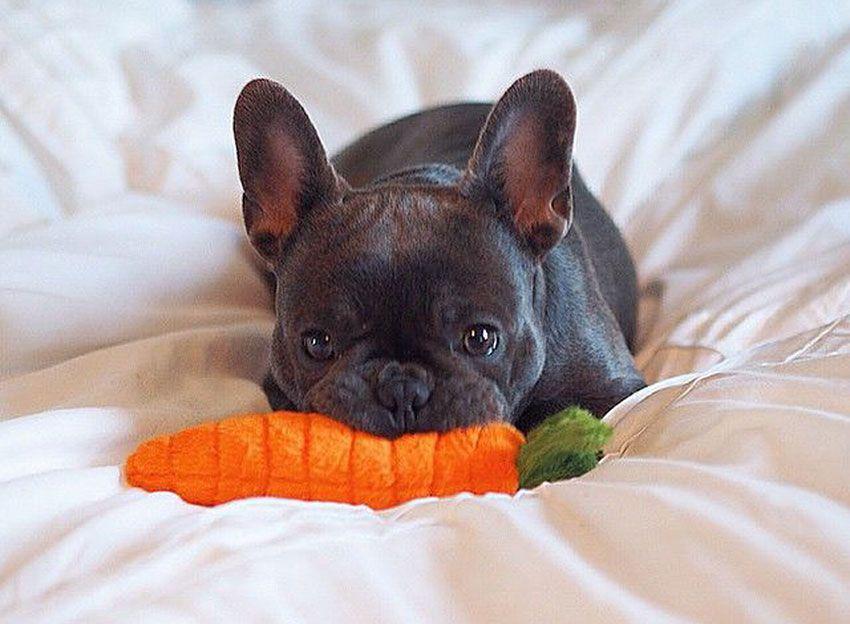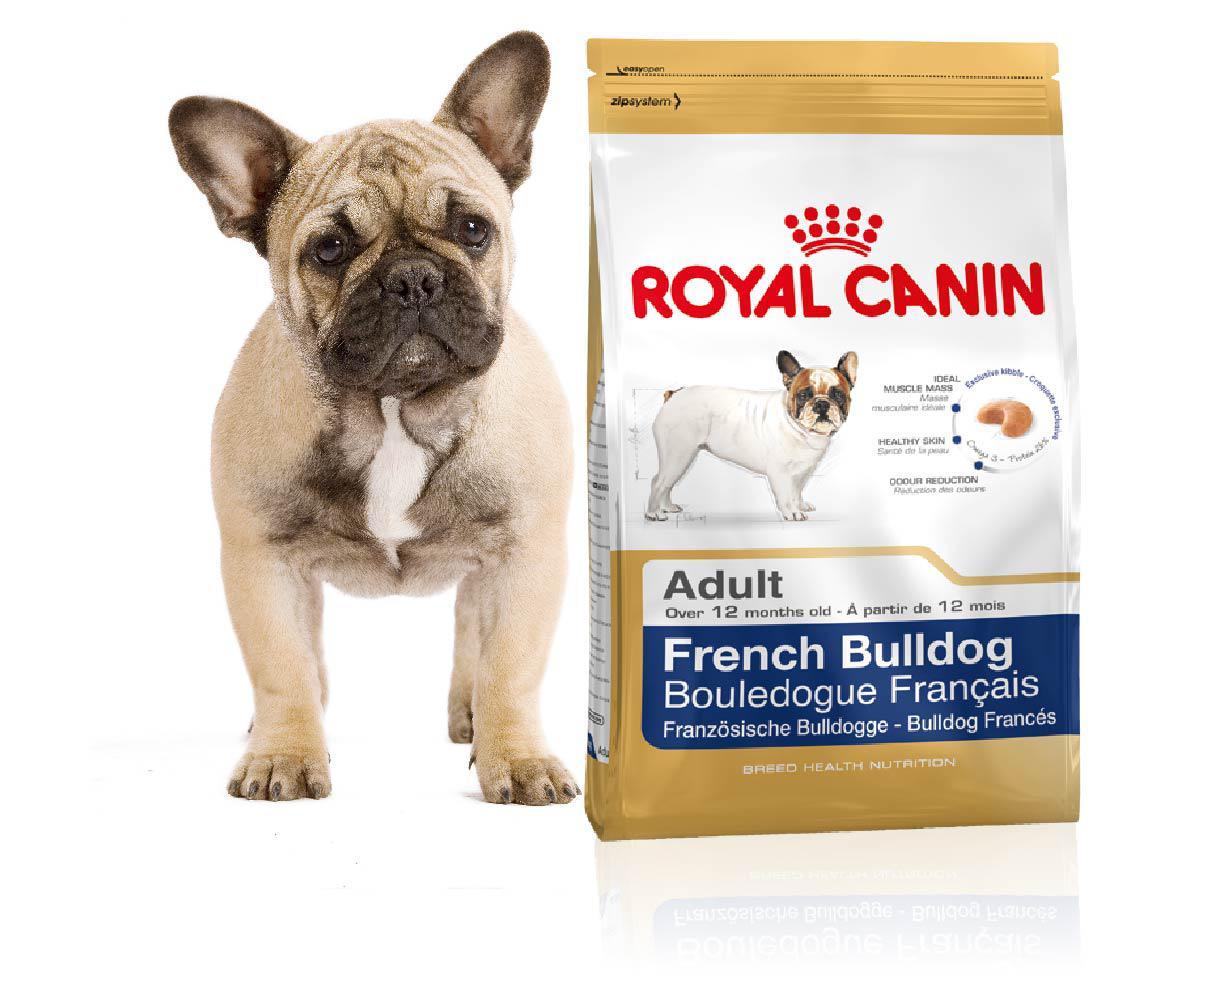The first image is the image on the left, the second image is the image on the right. For the images shown, is this caption "Each image shows a dog with a food bowl in front of it." true? Answer yes or no. No. The first image is the image on the left, the second image is the image on the right. For the images shown, is this caption "In at least one image ther is a small black puppy in a grey harness eating out of a green bowl." true? Answer yes or no. No. 